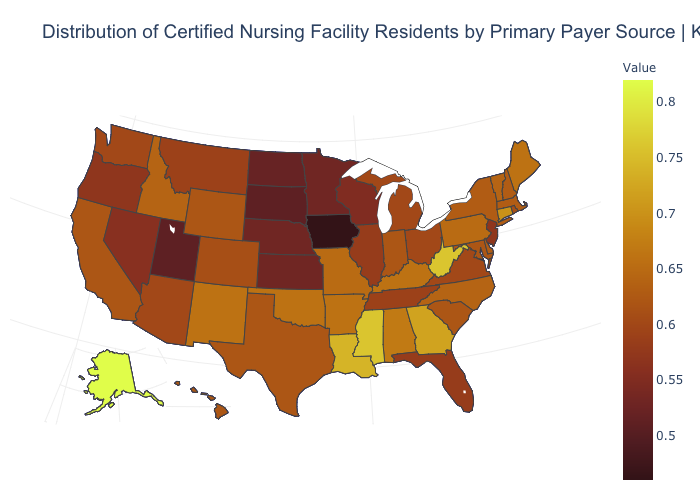Does Arizona have a higher value than Louisiana?
Quick response, please. No. Does Florida have the lowest value in the South?
Concise answer only. Yes. Which states have the highest value in the USA?
Give a very brief answer. Alaska. 